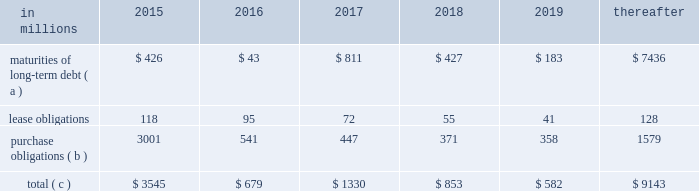The company will continue to rely upon debt and capital markets for the majority of any necessary long-term funding not provided by operating cash flows .
Funding decisions will be guided by our capital structure planning objectives .
The primary goals of the company 2019s capital structure planning are to maximize financial flexibility and preserve liquidity while reducing interest expense .
The majority of international paper 2019s debt is accessed through global public capital markets where we have a wide base of investors .
Maintaining an investment grade credit rating is an important element of international paper 2019s financing strategy .
At december 31 , 2015 , the company held long-term credit ratings of bbb ( stable outlook ) and baa2 ( stable outlook ) by s&p and moody 2019s , respectively .
Contractual obligations for future payments under existing debt and lease commitments and purchase obligations at december 31 , 2015 , were as follows: .
( a ) total debt includes scheduled principal payments only .
( b ) includes $ 2.1 billion relating to fiber supply agreements entered into at the time of the 2006 transformation plan forestland sales and in conjunction with the 2008 acquisition of weyerhaeuser company 2019s containerboard , packaging and recycling business .
( c ) not included in the above table due to the uncertainty as to the amount and timing of the payment are unrecognized tax benefits of approximately $ 101 million .
We consider the undistributed earnings of our foreign subsidiaries as of december 31 , 2015 , to be indefinitely reinvested and , accordingly , no u.s .
Income taxes have been provided thereon .
As of december 31 , 2015 , the amount of cash associated with indefinitely reinvested foreign earnings was approximately $ 600 million .
We do not anticipate the need to repatriate funds to the united states to satisfy domestic liquidity needs arising in the ordinary course of business , including liquidity needs associated with our domestic debt service requirements .
Pension obligations and funding at december 31 , 2015 , the projected benefit obligation for the company 2019s u.s .
Defined benefit plans determined under u.s .
Gaap was approximately $ 3.5 billion higher than the fair value of plan assets .
Approximately $ 3.2 billion of this amount relates to plans that are subject to minimum funding requirements .
Under current irs funding rules , the calculation of minimum funding requirements differs from the calculation of the present value of plan benefits ( the projected benefit obligation ) for accounting purposes .
In december 2008 , the worker , retiree and employer recovery act of 2008 ( wera ) was passed by the u.s .
Congress which provided for pension funding relief and technical corrections .
Funding contributions depend on the funding method selected by the company , and the timing of its implementation , as well as on actual demographic data and the targeted funding level .
The company continually reassesses the amount and timing of any discretionary contributions and elected to make contributions totaling $ 750 million and $ 353 million for the years ended december 31 , 2015 and 2014 , respectively .
At this time , we do not expect to have any required contributions to our plans in 2016 , although the company may elect to make future voluntary contributions .
The timing and amount of future contributions , which could be material , will depend on a number of factors , including the actual earnings and changes in values of plan assets and changes in interest rates .
International paper has announced a voluntary , limited-time opportunity for former employees who are participants in the retirement plan of international paper company ( the pension plan ) to request early payment of their entire pension plan benefit in the form of a single lump sum payment .
Eligible participants who wish to receive the lump sum payment must make an election between february 29 and april 29 , 2016 , and payment is scheduled to be made on or before june 30 , 2016 .
All payments will be made from the pension plan trust assets .
The target population has a total liability of $ 3.0 billion .
The amount of the total payments will depend on the participation rate of eligible participants , but is expected to be approximately $ 1.5 billion .
Based on the expected level of payments , settlement accounting rules will apply in the period in which the payments are made .
This will result in a plan remeasurement and the recognition in earnings of a pro-rata portion of unamortized net actuarial loss .
Ilim holding s.a .
Shareholder 2019s agreement in october 2007 , in connection with the formation of the ilim holding s.a .
Joint venture , international paper entered into a shareholder 2019s agreement that includes provisions relating to the reconciliation of disputes among the partners .
This agreement was amended on may 7 , 2014 .
Pursuant to the amended agreement , beginning on january 1 , 2017 , either the company or its partners may commence certain procedures specified under the deadlock provisions .
If these or any other deadlock provisions are commenced , the company may in certain situations , choose to purchase its partners 2019 50% ( 50 % ) interest in ilim .
Any such transaction would be subject to review and approval by russian and other relevant antitrust authorities .
Any such purchase by international paper would result in the consolidation of ilim 2019s financial position and results of operations in all subsequent periods. .
What percentage of contractual obligations for future payments under existing debt and lease commitments and purchase obligations at december 31 , 2015 are due to maturities of long-term debt in 2016? 
Computations: (43 / 679)
Answer: 0.06333. The company will continue to rely upon debt and capital markets for the majority of any necessary long-term funding not provided by operating cash flows .
Funding decisions will be guided by our capital structure planning objectives .
The primary goals of the company 2019s capital structure planning are to maximize financial flexibility and preserve liquidity while reducing interest expense .
The majority of international paper 2019s debt is accessed through global public capital markets where we have a wide base of investors .
Maintaining an investment grade credit rating is an important element of international paper 2019s financing strategy .
At december 31 , 2015 , the company held long-term credit ratings of bbb ( stable outlook ) and baa2 ( stable outlook ) by s&p and moody 2019s , respectively .
Contractual obligations for future payments under existing debt and lease commitments and purchase obligations at december 31 , 2015 , were as follows: .
( a ) total debt includes scheduled principal payments only .
( b ) includes $ 2.1 billion relating to fiber supply agreements entered into at the time of the 2006 transformation plan forestland sales and in conjunction with the 2008 acquisition of weyerhaeuser company 2019s containerboard , packaging and recycling business .
( c ) not included in the above table due to the uncertainty as to the amount and timing of the payment are unrecognized tax benefits of approximately $ 101 million .
We consider the undistributed earnings of our foreign subsidiaries as of december 31 , 2015 , to be indefinitely reinvested and , accordingly , no u.s .
Income taxes have been provided thereon .
As of december 31 , 2015 , the amount of cash associated with indefinitely reinvested foreign earnings was approximately $ 600 million .
We do not anticipate the need to repatriate funds to the united states to satisfy domestic liquidity needs arising in the ordinary course of business , including liquidity needs associated with our domestic debt service requirements .
Pension obligations and funding at december 31 , 2015 , the projected benefit obligation for the company 2019s u.s .
Defined benefit plans determined under u.s .
Gaap was approximately $ 3.5 billion higher than the fair value of plan assets .
Approximately $ 3.2 billion of this amount relates to plans that are subject to minimum funding requirements .
Under current irs funding rules , the calculation of minimum funding requirements differs from the calculation of the present value of plan benefits ( the projected benefit obligation ) for accounting purposes .
In december 2008 , the worker , retiree and employer recovery act of 2008 ( wera ) was passed by the u.s .
Congress which provided for pension funding relief and technical corrections .
Funding contributions depend on the funding method selected by the company , and the timing of its implementation , as well as on actual demographic data and the targeted funding level .
The company continually reassesses the amount and timing of any discretionary contributions and elected to make contributions totaling $ 750 million and $ 353 million for the years ended december 31 , 2015 and 2014 , respectively .
At this time , we do not expect to have any required contributions to our plans in 2016 , although the company may elect to make future voluntary contributions .
The timing and amount of future contributions , which could be material , will depend on a number of factors , including the actual earnings and changes in values of plan assets and changes in interest rates .
International paper has announced a voluntary , limited-time opportunity for former employees who are participants in the retirement plan of international paper company ( the pension plan ) to request early payment of their entire pension plan benefit in the form of a single lump sum payment .
Eligible participants who wish to receive the lump sum payment must make an election between february 29 and april 29 , 2016 , and payment is scheduled to be made on or before june 30 , 2016 .
All payments will be made from the pension plan trust assets .
The target population has a total liability of $ 3.0 billion .
The amount of the total payments will depend on the participation rate of eligible participants , but is expected to be approximately $ 1.5 billion .
Based on the expected level of payments , settlement accounting rules will apply in the period in which the payments are made .
This will result in a plan remeasurement and the recognition in earnings of a pro-rata portion of unamortized net actuarial loss .
Ilim holding s.a .
Shareholder 2019s agreement in october 2007 , in connection with the formation of the ilim holding s.a .
Joint venture , international paper entered into a shareholder 2019s agreement that includes provisions relating to the reconciliation of disputes among the partners .
This agreement was amended on may 7 , 2014 .
Pursuant to the amended agreement , beginning on january 1 , 2017 , either the company or its partners may commence certain procedures specified under the deadlock provisions .
If these or any other deadlock provisions are commenced , the company may in certain situations , choose to purchase its partners 2019 50% ( 50 % ) interest in ilim .
Any such transaction would be subject to review and approval by russian and other relevant antitrust authorities .
Any such purchase by international paper would result in the consolidation of ilim 2019s financial position and results of operations in all subsequent periods. .
In 2018 what was the percent of the long-term debt maturities as part of the total contractual obligations for future payments? 
Computations: (427 / 853)
Answer: 0.50059. 